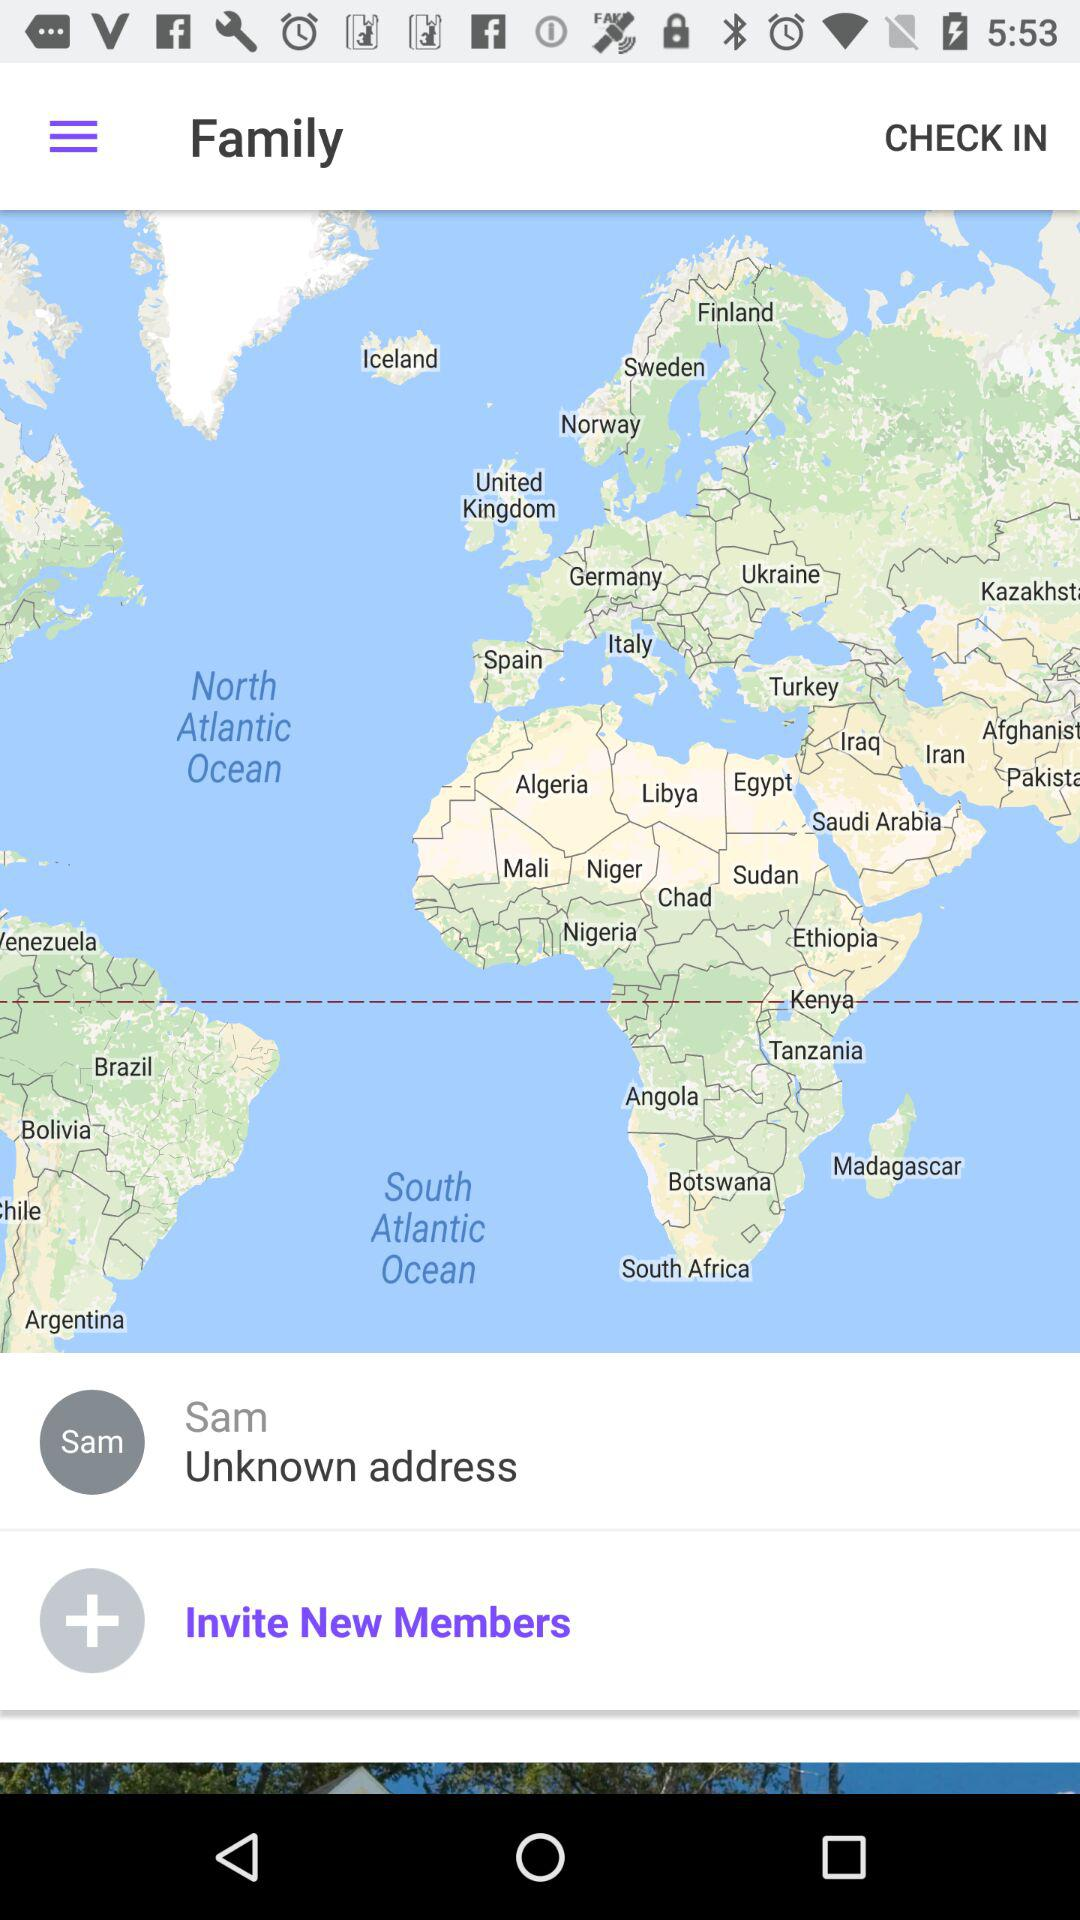Who published the map?
When the provided information is insufficient, respond with <no answer>. <no answer> 